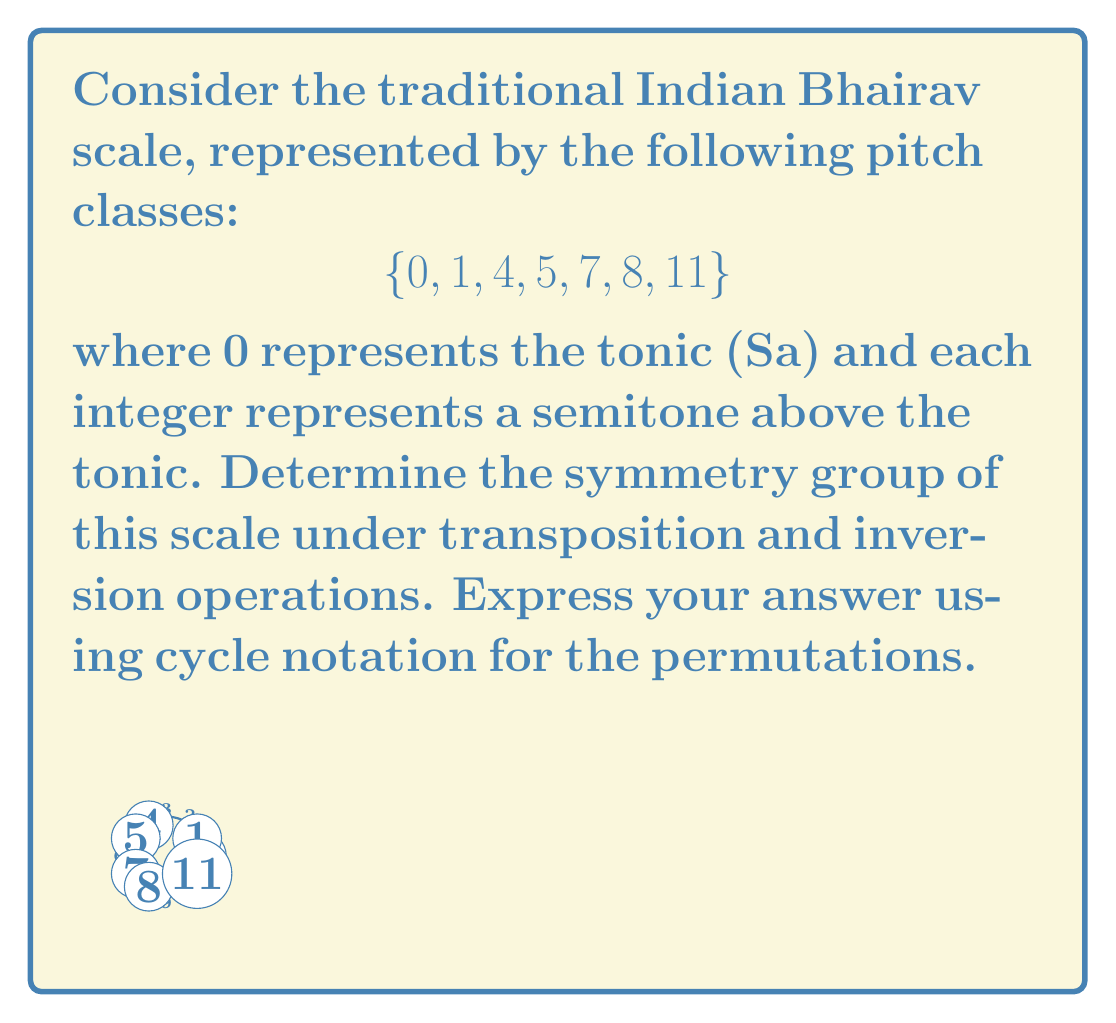Give your solution to this math problem. To determine the symmetry group of the Bhairav scale, we need to find all transpositions and inversions that map the scale onto itself. Let's approach this step-by-step:

1) First, let's consider transpositions:
   - T0 (identity): $(0,1,4,5,7,8,11)$
   - No other transposition maps the scale onto itself.

2) Now, let's consider inversions:
   - I0: $(0,11,8,7,5,4,1)$ - This is a valid symmetry.
   - I6: $(6,5,2,1,11,10,7)$ - This is not a valid symmetry.
   - No other inversions produce a valid symmetry.

3) The symmetry group consists of two elements: the identity transformation and the inversion around 0.

4) To express these as permutations in cycle notation:
   - Identity: $(0)(1)(4)(5)(7)(8)(11)$
   - Inversion I0: $(0)(1,11)(4,8)(5,7)$

5) This group has only two elements and is isomorphic to the cyclic group of order 2, $C_2$ or $\mathbb{Z}_2$.

The symmetry group can be written as:
$$G = \{(0)(1)(4)(5)(7)(8)(11), (0)(1,11)(4,8)(5,7)\}$$
Answer: $\{(0)(1)(4)(5)(7)(8)(11), (0)(1,11)(4,8)(5,7)\}$ 